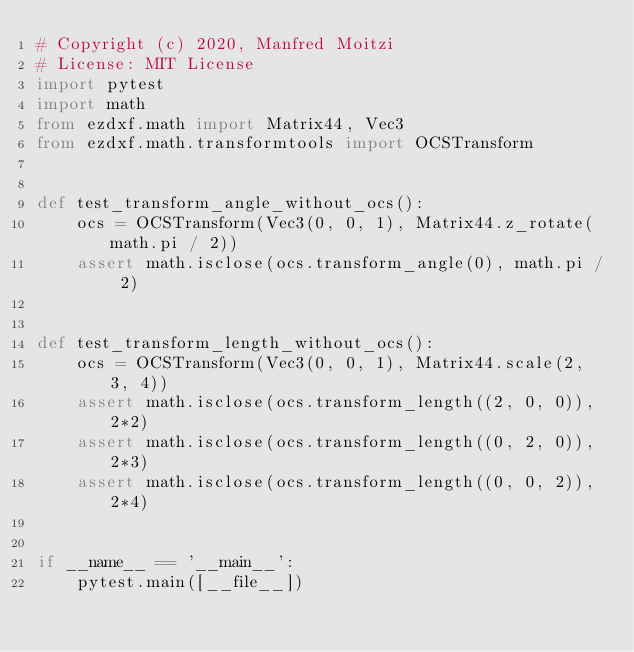<code> <loc_0><loc_0><loc_500><loc_500><_Python_># Copyright (c) 2020, Manfred Moitzi
# License: MIT License
import pytest
import math
from ezdxf.math import Matrix44, Vec3
from ezdxf.math.transformtools import OCSTransform


def test_transform_angle_without_ocs():
    ocs = OCSTransform(Vec3(0, 0, 1), Matrix44.z_rotate(math.pi / 2))
    assert math.isclose(ocs.transform_angle(0), math.pi / 2)


def test_transform_length_without_ocs():
    ocs = OCSTransform(Vec3(0, 0, 1), Matrix44.scale(2, 3, 4))
    assert math.isclose(ocs.transform_length((2, 0, 0)), 2*2)
    assert math.isclose(ocs.transform_length((0, 2, 0)), 2*3)
    assert math.isclose(ocs.transform_length((0, 0, 2)), 2*4)


if __name__ == '__main__':
    pytest.main([__file__])
</code> 